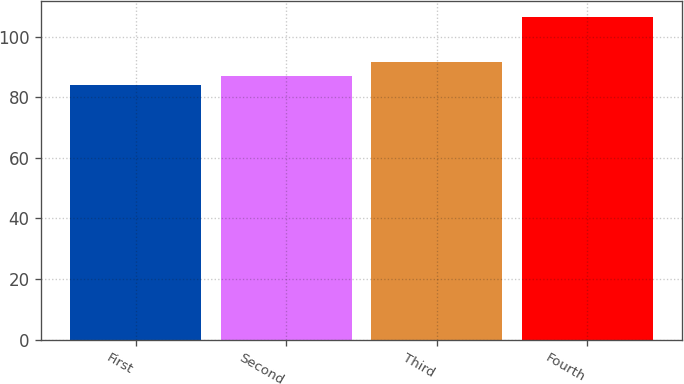Convert chart to OTSL. <chart><loc_0><loc_0><loc_500><loc_500><bar_chart><fcel>First<fcel>Second<fcel>Third<fcel>Fourth<nl><fcel>84.02<fcel>87.12<fcel>91.57<fcel>106.57<nl></chart> 